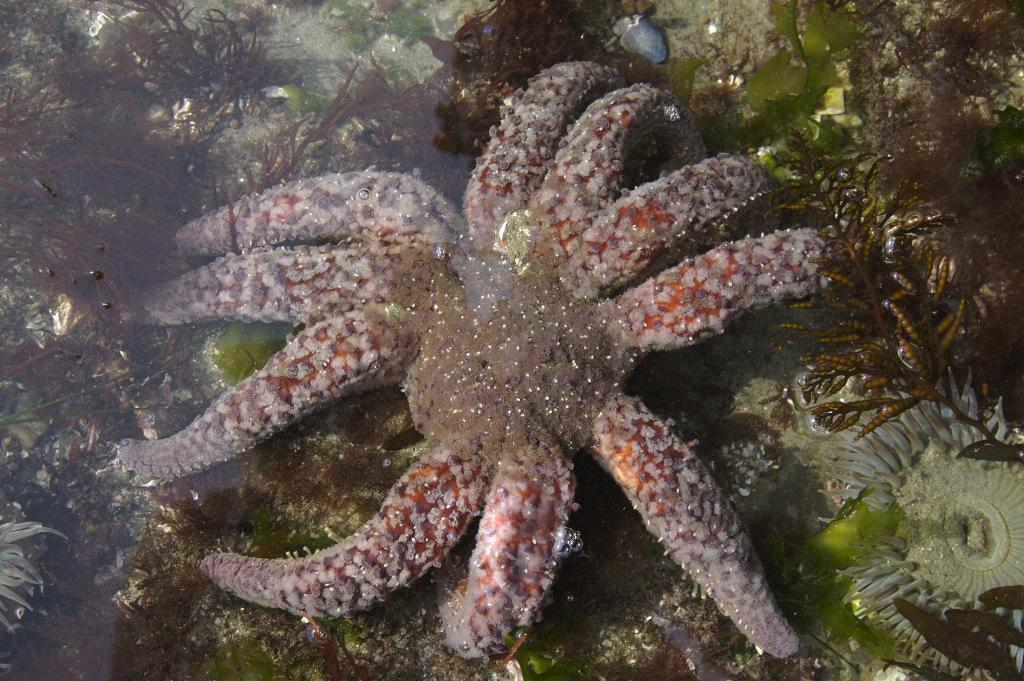What type of animal is in the water in the image? There is a starfish in the water in the image. What else can be seen in the water besides the starfish? There are plants in the water. What type of peace treaty is being signed in the image? There is no peace treaty or any indication of a signing ceremony in the image; it features a starfish and plants in the water. 